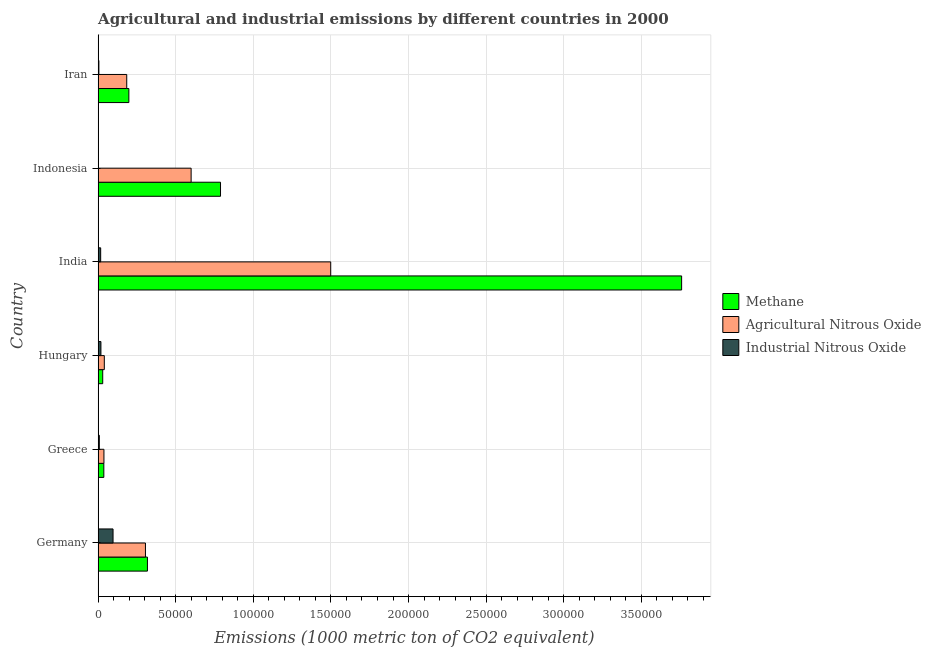How many different coloured bars are there?
Provide a succinct answer. 3. How many groups of bars are there?
Give a very brief answer. 6. Are the number of bars per tick equal to the number of legend labels?
Keep it short and to the point. Yes. How many bars are there on the 1st tick from the bottom?
Give a very brief answer. 3. What is the label of the 5th group of bars from the top?
Ensure brevity in your answer.  Greece. What is the amount of agricultural nitrous oxide emissions in Indonesia?
Keep it short and to the point. 5.99e+04. Across all countries, what is the maximum amount of agricultural nitrous oxide emissions?
Keep it short and to the point. 1.50e+05. Across all countries, what is the minimum amount of methane emissions?
Make the answer very short. 2961.9. In which country was the amount of agricultural nitrous oxide emissions maximum?
Your response must be concise. India. What is the total amount of agricultural nitrous oxide emissions in the graph?
Offer a very short reply. 2.66e+05. What is the difference between the amount of methane emissions in Germany and that in Greece?
Provide a succinct answer. 2.81e+04. What is the difference between the amount of agricultural nitrous oxide emissions in Iran and the amount of industrial nitrous oxide emissions in India?
Your response must be concise. 1.68e+04. What is the average amount of agricultural nitrous oxide emissions per country?
Make the answer very short. 4.44e+04. What is the difference between the amount of industrial nitrous oxide emissions and amount of methane emissions in Indonesia?
Provide a succinct answer. -7.87e+04. In how many countries, is the amount of agricultural nitrous oxide emissions greater than 210000 metric ton?
Offer a very short reply. 0. What is the ratio of the amount of methane emissions in India to that in Indonesia?
Ensure brevity in your answer.  4.77. Is the amount of industrial nitrous oxide emissions in Hungary less than that in Indonesia?
Ensure brevity in your answer.  No. What is the difference between the highest and the second highest amount of methane emissions?
Offer a terse response. 2.97e+05. What is the difference between the highest and the lowest amount of agricultural nitrous oxide emissions?
Make the answer very short. 1.46e+05. Is the sum of the amount of agricultural nitrous oxide emissions in Hungary and Iran greater than the maximum amount of methane emissions across all countries?
Offer a terse response. No. What does the 1st bar from the top in Hungary represents?
Make the answer very short. Industrial Nitrous Oxide. What does the 2nd bar from the bottom in Indonesia represents?
Offer a very short reply. Agricultural Nitrous Oxide. How many bars are there?
Keep it short and to the point. 18. Are all the bars in the graph horizontal?
Provide a succinct answer. Yes. How many countries are there in the graph?
Offer a very short reply. 6. Are the values on the major ticks of X-axis written in scientific E-notation?
Ensure brevity in your answer.  No. How are the legend labels stacked?
Your answer should be compact. Vertical. What is the title of the graph?
Your answer should be compact. Agricultural and industrial emissions by different countries in 2000. Does "Tertiary education" appear as one of the legend labels in the graph?
Offer a terse response. No. What is the label or title of the X-axis?
Provide a short and direct response. Emissions (1000 metric ton of CO2 equivalent). What is the label or title of the Y-axis?
Give a very brief answer. Country. What is the Emissions (1000 metric ton of CO2 equivalent) of Methane in Germany?
Offer a terse response. 3.18e+04. What is the Emissions (1000 metric ton of CO2 equivalent) in Agricultural Nitrous Oxide in Germany?
Make the answer very short. 3.05e+04. What is the Emissions (1000 metric ton of CO2 equivalent) in Industrial Nitrous Oxide in Germany?
Offer a terse response. 9617.9. What is the Emissions (1000 metric ton of CO2 equivalent) of Methane in Greece?
Give a very brief answer. 3679.3. What is the Emissions (1000 metric ton of CO2 equivalent) in Agricultural Nitrous Oxide in Greece?
Your answer should be compact. 3745.5. What is the Emissions (1000 metric ton of CO2 equivalent) of Industrial Nitrous Oxide in Greece?
Offer a terse response. 771. What is the Emissions (1000 metric ton of CO2 equivalent) in Methane in Hungary?
Offer a very short reply. 2961.9. What is the Emissions (1000 metric ton of CO2 equivalent) in Agricultural Nitrous Oxide in Hungary?
Provide a succinct answer. 3996.3. What is the Emissions (1000 metric ton of CO2 equivalent) of Industrial Nitrous Oxide in Hungary?
Your answer should be compact. 1805.4. What is the Emissions (1000 metric ton of CO2 equivalent) in Methane in India?
Make the answer very short. 3.76e+05. What is the Emissions (1000 metric ton of CO2 equivalent) of Agricultural Nitrous Oxide in India?
Provide a short and direct response. 1.50e+05. What is the Emissions (1000 metric ton of CO2 equivalent) of Industrial Nitrous Oxide in India?
Offer a terse response. 1643.3. What is the Emissions (1000 metric ton of CO2 equivalent) of Methane in Indonesia?
Offer a very short reply. 7.89e+04. What is the Emissions (1000 metric ton of CO2 equivalent) of Agricultural Nitrous Oxide in Indonesia?
Ensure brevity in your answer.  5.99e+04. What is the Emissions (1000 metric ton of CO2 equivalent) of Industrial Nitrous Oxide in Indonesia?
Provide a short and direct response. 175.8. What is the Emissions (1000 metric ton of CO2 equivalent) in Methane in Iran?
Provide a succinct answer. 1.98e+04. What is the Emissions (1000 metric ton of CO2 equivalent) in Agricultural Nitrous Oxide in Iran?
Provide a short and direct response. 1.84e+04. What is the Emissions (1000 metric ton of CO2 equivalent) in Industrial Nitrous Oxide in Iran?
Your answer should be very brief. 499.4. Across all countries, what is the maximum Emissions (1000 metric ton of CO2 equivalent) in Methane?
Give a very brief answer. 3.76e+05. Across all countries, what is the maximum Emissions (1000 metric ton of CO2 equivalent) of Agricultural Nitrous Oxide?
Give a very brief answer. 1.50e+05. Across all countries, what is the maximum Emissions (1000 metric ton of CO2 equivalent) in Industrial Nitrous Oxide?
Ensure brevity in your answer.  9617.9. Across all countries, what is the minimum Emissions (1000 metric ton of CO2 equivalent) in Methane?
Provide a succinct answer. 2961.9. Across all countries, what is the minimum Emissions (1000 metric ton of CO2 equivalent) of Agricultural Nitrous Oxide?
Give a very brief answer. 3745.5. Across all countries, what is the minimum Emissions (1000 metric ton of CO2 equivalent) in Industrial Nitrous Oxide?
Your answer should be very brief. 175.8. What is the total Emissions (1000 metric ton of CO2 equivalent) in Methane in the graph?
Provide a short and direct response. 5.13e+05. What is the total Emissions (1000 metric ton of CO2 equivalent) in Agricultural Nitrous Oxide in the graph?
Make the answer very short. 2.66e+05. What is the total Emissions (1000 metric ton of CO2 equivalent) of Industrial Nitrous Oxide in the graph?
Your answer should be compact. 1.45e+04. What is the difference between the Emissions (1000 metric ton of CO2 equivalent) in Methane in Germany and that in Greece?
Provide a short and direct response. 2.81e+04. What is the difference between the Emissions (1000 metric ton of CO2 equivalent) of Agricultural Nitrous Oxide in Germany and that in Greece?
Your answer should be very brief. 2.68e+04. What is the difference between the Emissions (1000 metric ton of CO2 equivalent) of Industrial Nitrous Oxide in Germany and that in Greece?
Offer a terse response. 8846.9. What is the difference between the Emissions (1000 metric ton of CO2 equivalent) of Methane in Germany and that in Hungary?
Your answer should be compact. 2.88e+04. What is the difference between the Emissions (1000 metric ton of CO2 equivalent) of Agricultural Nitrous Oxide in Germany and that in Hungary?
Give a very brief answer. 2.65e+04. What is the difference between the Emissions (1000 metric ton of CO2 equivalent) of Industrial Nitrous Oxide in Germany and that in Hungary?
Provide a succinct answer. 7812.5. What is the difference between the Emissions (1000 metric ton of CO2 equivalent) of Methane in Germany and that in India?
Give a very brief answer. -3.44e+05. What is the difference between the Emissions (1000 metric ton of CO2 equivalent) of Agricultural Nitrous Oxide in Germany and that in India?
Your answer should be very brief. -1.19e+05. What is the difference between the Emissions (1000 metric ton of CO2 equivalent) of Industrial Nitrous Oxide in Germany and that in India?
Keep it short and to the point. 7974.6. What is the difference between the Emissions (1000 metric ton of CO2 equivalent) of Methane in Germany and that in Indonesia?
Your answer should be compact. -4.71e+04. What is the difference between the Emissions (1000 metric ton of CO2 equivalent) in Agricultural Nitrous Oxide in Germany and that in Indonesia?
Provide a succinct answer. -2.94e+04. What is the difference between the Emissions (1000 metric ton of CO2 equivalent) in Industrial Nitrous Oxide in Germany and that in Indonesia?
Provide a short and direct response. 9442.1. What is the difference between the Emissions (1000 metric ton of CO2 equivalent) in Methane in Germany and that in Iran?
Your answer should be very brief. 1.20e+04. What is the difference between the Emissions (1000 metric ton of CO2 equivalent) in Agricultural Nitrous Oxide in Germany and that in Iran?
Offer a terse response. 1.21e+04. What is the difference between the Emissions (1000 metric ton of CO2 equivalent) of Industrial Nitrous Oxide in Germany and that in Iran?
Your answer should be very brief. 9118.5. What is the difference between the Emissions (1000 metric ton of CO2 equivalent) of Methane in Greece and that in Hungary?
Your response must be concise. 717.4. What is the difference between the Emissions (1000 metric ton of CO2 equivalent) in Agricultural Nitrous Oxide in Greece and that in Hungary?
Your answer should be very brief. -250.8. What is the difference between the Emissions (1000 metric ton of CO2 equivalent) of Industrial Nitrous Oxide in Greece and that in Hungary?
Your answer should be very brief. -1034.4. What is the difference between the Emissions (1000 metric ton of CO2 equivalent) in Methane in Greece and that in India?
Your response must be concise. -3.72e+05. What is the difference between the Emissions (1000 metric ton of CO2 equivalent) in Agricultural Nitrous Oxide in Greece and that in India?
Your response must be concise. -1.46e+05. What is the difference between the Emissions (1000 metric ton of CO2 equivalent) in Industrial Nitrous Oxide in Greece and that in India?
Offer a terse response. -872.3. What is the difference between the Emissions (1000 metric ton of CO2 equivalent) in Methane in Greece and that in Indonesia?
Offer a terse response. -7.52e+04. What is the difference between the Emissions (1000 metric ton of CO2 equivalent) in Agricultural Nitrous Oxide in Greece and that in Indonesia?
Offer a terse response. -5.62e+04. What is the difference between the Emissions (1000 metric ton of CO2 equivalent) of Industrial Nitrous Oxide in Greece and that in Indonesia?
Offer a terse response. 595.2. What is the difference between the Emissions (1000 metric ton of CO2 equivalent) in Methane in Greece and that in Iran?
Your answer should be very brief. -1.61e+04. What is the difference between the Emissions (1000 metric ton of CO2 equivalent) of Agricultural Nitrous Oxide in Greece and that in Iran?
Offer a very short reply. -1.47e+04. What is the difference between the Emissions (1000 metric ton of CO2 equivalent) in Industrial Nitrous Oxide in Greece and that in Iran?
Offer a terse response. 271.6. What is the difference between the Emissions (1000 metric ton of CO2 equivalent) in Methane in Hungary and that in India?
Keep it short and to the point. -3.73e+05. What is the difference between the Emissions (1000 metric ton of CO2 equivalent) of Agricultural Nitrous Oxide in Hungary and that in India?
Provide a succinct answer. -1.46e+05. What is the difference between the Emissions (1000 metric ton of CO2 equivalent) in Industrial Nitrous Oxide in Hungary and that in India?
Offer a very short reply. 162.1. What is the difference between the Emissions (1000 metric ton of CO2 equivalent) in Methane in Hungary and that in Indonesia?
Offer a terse response. -7.59e+04. What is the difference between the Emissions (1000 metric ton of CO2 equivalent) of Agricultural Nitrous Oxide in Hungary and that in Indonesia?
Give a very brief answer. -5.59e+04. What is the difference between the Emissions (1000 metric ton of CO2 equivalent) of Industrial Nitrous Oxide in Hungary and that in Indonesia?
Your answer should be very brief. 1629.6. What is the difference between the Emissions (1000 metric ton of CO2 equivalent) of Methane in Hungary and that in Iran?
Offer a very short reply. -1.68e+04. What is the difference between the Emissions (1000 metric ton of CO2 equivalent) of Agricultural Nitrous Oxide in Hungary and that in Iran?
Keep it short and to the point. -1.44e+04. What is the difference between the Emissions (1000 metric ton of CO2 equivalent) in Industrial Nitrous Oxide in Hungary and that in Iran?
Keep it short and to the point. 1306. What is the difference between the Emissions (1000 metric ton of CO2 equivalent) in Methane in India and that in Indonesia?
Provide a short and direct response. 2.97e+05. What is the difference between the Emissions (1000 metric ton of CO2 equivalent) of Agricultural Nitrous Oxide in India and that in Indonesia?
Your response must be concise. 8.99e+04. What is the difference between the Emissions (1000 metric ton of CO2 equivalent) of Industrial Nitrous Oxide in India and that in Indonesia?
Your response must be concise. 1467.5. What is the difference between the Emissions (1000 metric ton of CO2 equivalent) of Methane in India and that in Iran?
Provide a short and direct response. 3.56e+05. What is the difference between the Emissions (1000 metric ton of CO2 equivalent) in Agricultural Nitrous Oxide in India and that in Iran?
Your answer should be compact. 1.31e+05. What is the difference between the Emissions (1000 metric ton of CO2 equivalent) in Industrial Nitrous Oxide in India and that in Iran?
Offer a terse response. 1143.9. What is the difference between the Emissions (1000 metric ton of CO2 equivalent) of Methane in Indonesia and that in Iran?
Ensure brevity in your answer.  5.91e+04. What is the difference between the Emissions (1000 metric ton of CO2 equivalent) of Agricultural Nitrous Oxide in Indonesia and that in Iran?
Your answer should be very brief. 4.15e+04. What is the difference between the Emissions (1000 metric ton of CO2 equivalent) of Industrial Nitrous Oxide in Indonesia and that in Iran?
Provide a short and direct response. -323.6. What is the difference between the Emissions (1000 metric ton of CO2 equivalent) of Methane in Germany and the Emissions (1000 metric ton of CO2 equivalent) of Agricultural Nitrous Oxide in Greece?
Offer a very short reply. 2.80e+04. What is the difference between the Emissions (1000 metric ton of CO2 equivalent) in Methane in Germany and the Emissions (1000 metric ton of CO2 equivalent) in Industrial Nitrous Oxide in Greece?
Your answer should be very brief. 3.10e+04. What is the difference between the Emissions (1000 metric ton of CO2 equivalent) of Agricultural Nitrous Oxide in Germany and the Emissions (1000 metric ton of CO2 equivalent) of Industrial Nitrous Oxide in Greece?
Keep it short and to the point. 2.97e+04. What is the difference between the Emissions (1000 metric ton of CO2 equivalent) of Methane in Germany and the Emissions (1000 metric ton of CO2 equivalent) of Agricultural Nitrous Oxide in Hungary?
Give a very brief answer. 2.78e+04. What is the difference between the Emissions (1000 metric ton of CO2 equivalent) in Methane in Germany and the Emissions (1000 metric ton of CO2 equivalent) in Industrial Nitrous Oxide in Hungary?
Offer a terse response. 3.00e+04. What is the difference between the Emissions (1000 metric ton of CO2 equivalent) in Agricultural Nitrous Oxide in Germany and the Emissions (1000 metric ton of CO2 equivalent) in Industrial Nitrous Oxide in Hungary?
Your answer should be very brief. 2.87e+04. What is the difference between the Emissions (1000 metric ton of CO2 equivalent) of Methane in Germany and the Emissions (1000 metric ton of CO2 equivalent) of Agricultural Nitrous Oxide in India?
Give a very brief answer. -1.18e+05. What is the difference between the Emissions (1000 metric ton of CO2 equivalent) of Methane in Germany and the Emissions (1000 metric ton of CO2 equivalent) of Industrial Nitrous Oxide in India?
Provide a succinct answer. 3.01e+04. What is the difference between the Emissions (1000 metric ton of CO2 equivalent) of Agricultural Nitrous Oxide in Germany and the Emissions (1000 metric ton of CO2 equivalent) of Industrial Nitrous Oxide in India?
Your response must be concise. 2.89e+04. What is the difference between the Emissions (1000 metric ton of CO2 equivalent) of Methane in Germany and the Emissions (1000 metric ton of CO2 equivalent) of Agricultural Nitrous Oxide in Indonesia?
Your answer should be very brief. -2.82e+04. What is the difference between the Emissions (1000 metric ton of CO2 equivalent) of Methane in Germany and the Emissions (1000 metric ton of CO2 equivalent) of Industrial Nitrous Oxide in Indonesia?
Your answer should be very brief. 3.16e+04. What is the difference between the Emissions (1000 metric ton of CO2 equivalent) in Agricultural Nitrous Oxide in Germany and the Emissions (1000 metric ton of CO2 equivalent) in Industrial Nitrous Oxide in Indonesia?
Your answer should be compact. 3.03e+04. What is the difference between the Emissions (1000 metric ton of CO2 equivalent) in Methane in Germany and the Emissions (1000 metric ton of CO2 equivalent) in Agricultural Nitrous Oxide in Iran?
Provide a short and direct response. 1.33e+04. What is the difference between the Emissions (1000 metric ton of CO2 equivalent) in Methane in Germany and the Emissions (1000 metric ton of CO2 equivalent) in Industrial Nitrous Oxide in Iran?
Your answer should be very brief. 3.13e+04. What is the difference between the Emissions (1000 metric ton of CO2 equivalent) in Agricultural Nitrous Oxide in Germany and the Emissions (1000 metric ton of CO2 equivalent) in Industrial Nitrous Oxide in Iran?
Provide a short and direct response. 3.00e+04. What is the difference between the Emissions (1000 metric ton of CO2 equivalent) in Methane in Greece and the Emissions (1000 metric ton of CO2 equivalent) in Agricultural Nitrous Oxide in Hungary?
Provide a short and direct response. -317. What is the difference between the Emissions (1000 metric ton of CO2 equivalent) in Methane in Greece and the Emissions (1000 metric ton of CO2 equivalent) in Industrial Nitrous Oxide in Hungary?
Your answer should be compact. 1873.9. What is the difference between the Emissions (1000 metric ton of CO2 equivalent) in Agricultural Nitrous Oxide in Greece and the Emissions (1000 metric ton of CO2 equivalent) in Industrial Nitrous Oxide in Hungary?
Offer a very short reply. 1940.1. What is the difference between the Emissions (1000 metric ton of CO2 equivalent) in Methane in Greece and the Emissions (1000 metric ton of CO2 equivalent) in Agricultural Nitrous Oxide in India?
Your response must be concise. -1.46e+05. What is the difference between the Emissions (1000 metric ton of CO2 equivalent) of Methane in Greece and the Emissions (1000 metric ton of CO2 equivalent) of Industrial Nitrous Oxide in India?
Keep it short and to the point. 2036. What is the difference between the Emissions (1000 metric ton of CO2 equivalent) of Agricultural Nitrous Oxide in Greece and the Emissions (1000 metric ton of CO2 equivalent) of Industrial Nitrous Oxide in India?
Keep it short and to the point. 2102.2. What is the difference between the Emissions (1000 metric ton of CO2 equivalent) in Methane in Greece and the Emissions (1000 metric ton of CO2 equivalent) in Agricultural Nitrous Oxide in Indonesia?
Make the answer very short. -5.62e+04. What is the difference between the Emissions (1000 metric ton of CO2 equivalent) in Methane in Greece and the Emissions (1000 metric ton of CO2 equivalent) in Industrial Nitrous Oxide in Indonesia?
Provide a short and direct response. 3503.5. What is the difference between the Emissions (1000 metric ton of CO2 equivalent) in Agricultural Nitrous Oxide in Greece and the Emissions (1000 metric ton of CO2 equivalent) in Industrial Nitrous Oxide in Indonesia?
Provide a succinct answer. 3569.7. What is the difference between the Emissions (1000 metric ton of CO2 equivalent) in Methane in Greece and the Emissions (1000 metric ton of CO2 equivalent) in Agricultural Nitrous Oxide in Iran?
Your response must be concise. -1.48e+04. What is the difference between the Emissions (1000 metric ton of CO2 equivalent) in Methane in Greece and the Emissions (1000 metric ton of CO2 equivalent) in Industrial Nitrous Oxide in Iran?
Ensure brevity in your answer.  3179.9. What is the difference between the Emissions (1000 metric ton of CO2 equivalent) of Agricultural Nitrous Oxide in Greece and the Emissions (1000 metric ton of CO2 equivalent) of Industrial Nitrous Oxide in Iran?
Offer a very short reply. 3246.1. What is the difference between the Emissions (1000 metric ton of CO2 equivalent) of Methane in Hungary and the Emissions (1000 metric ton of CO2 equivalent) of Agricultural Nitrous Oxide in India?
Your answer should be very brief. -1.47e+05. What is the difference between the Emissions (1000 metric ton of CO2 equivalent) of Methane in Hungary and the Emissions (1000 metric ton of CO2 equivalent) of Industrial Nitrous Oxide in India?
Keep it short and to the point. 1318.6. What is the difference between the Emissions (1000 metric ton of CO2 equivalent) of Agricultural Nitrous Oxide in Hungary and the Emissions (1000 metric ton of CO2 equivalent) of Industrial Nitrous Oxide in India?
Your answer should be compact. 2353. What is the difference between the Emissions (1000 metric ton of CO2 equivalent) in Methane in Hungary and the Emissions (1000 metric ton of CO2 equivalent) in Agricultural Nitrous Oxide in Indonesia?
Your answer should be very brief. -5.70e+04. What is the difference between the Emissions (1000 metric ton of CO2 equivalent) in Methane in Hungary and the Emissions (1000 metric ton of CO2 equivalent) in Industrial Nitrous Oxide in Indonesia?
Give a very brief answer. 2786.1. What is the difference between the Emissions (1000 metric ton of CO2 equivalent) of Agricultural Nitrous Oxide in Hungary and the Emissions (1000 metric ton of CO2 equivalent) of Industrial Nitrous Oxide in Indonesia?
Your answer should be very brief. 3820.5. What is the difference between the Emissions (1000 metric ton of CO2 equivalent) of Methane in Hungary and the Emissions (1000 metric ton of CO2 equivalent) of Agricultural Nitrous Oxide in Iran?
Ensure brevity in your answer.  -1.55e+04. What is the difference between the Emissions (1000 metric ton of CO2 equivalent) in Methane in Hungary and the Emissions (1000 metric ton of CO2 equivalent) in Industrial Nitrous Oxide in Iran?
Your answer should be very brief. 2462.5. What is the difference between the Emissions (1000 metric ton of CO2 equivalent) in Agricultural Nitrous Oxide in Hungary and the Emissions (1000 metric ton of CO2 equivalent) in Industrial Nitrous Oxide in Iran?
Provide a short and direct response. 3496.9. What is the difference between the Emissions (1000 metric ton of CO2 equivalent) in Methane in India and the Emissions (1000 metric ton of CO2 equivalent) in Agricultural Nitrous Oxide in Indonesia?
Your answer should be very brief. 3.16e+05. What is the difference between the Emissions (1000 metric ton of CO2 equivalent) of Methane in India and the Emissions (1000 metric ton of CO2 equivalent) of Industrial Nitrous Oxide in Indonesia?
Your answer should be compact. 3.76e+05. What is the difference between the Emissions (1000 metric ton of CO2 equivalent) in Agricultural Nitrous Oxide in India and the Emissions (1000 metric ton of CO2 equivalent) in Industrial Nitrous Oxide in Indonesia?
Provide a short and direct response. 1.50e+05. What is the difference between the Emissions (1000 metric ton of CO2 equivalent) of Methane in India and the Emissions (1000 metric ton of CO2 equivalent) of Agricultural Nitrous Oxide in Iran?
Give a very brief answer. 3.58e+05. What is the difference between the Emissions (1000 metric ton of CO2 equivalent) in Methane in India and the Emissions (1000 metric ton of CO2 equivalent) in Industrial Nitrous Oxide in Iran?
Your answer should be very brief. 3.75e+05. What is the difference between the Emissions (1000 metric ton of CO2 equivalent) in Agricultural Nitrous Oxide in India and the Emissions (1000 metric ton of CO2 equivalent) in Industrial Nitrous Oxide in Iran?
Ensure brevity in your answer.  1.49e+05. What is the difference between the Emissions (1000 metric ton of CO2 equivalent) of Methane in Indonesia and the Emissions (1000 metric ton of CO2 equivalent) of Agricultural Nitrous Oxide in Iran?
Provide a succinct answer. 6.04e+04. What is the difference between the Emissions (1000 metric ton of CO2 equivalent) of Methane in Indonesia and the Emissions (1000 metric ton of CO2 equivalent) of Industrial Nitrous Oxide in Iran?
Make the answer very short. 7.84e+04. What is the difference between the Emissions (1000 metric ton of CO2 equivalent) in Agricultural Nitrous Oxide in Indonesia and the Emissions (1000 metric ton of CO2 equivalent) in Industrial Nitrous Oxide in Iran?
Your answer should be very brief. 5.94e+04. What is the average Emissions (1000 metric ton of CO2 equivalent) of Methane per country?
Ensure brevity in your answer.  8.55e+04. What is the average Emissions (1000 metric ton of CO2 equivalent) in Agricultural Nitrous Oxide per country?
Ensure brevity in your answer.  4.44e+04. What is the average Emissions (1000 metric ton of CO2 equivalent) in Industrial Nitrous Oxide per country?
Your answer should be compact. 2418.8. What is the difference between the Emissions (1000 metric ton of CO2 equivalent) of Methane and Emissions (1000 metric ton of CO2 equivalent) of Agricultural Nitrous Oxide in Germany?
Ensure brevity in your answer.  1273.5. What is the difference between the Emissions (1000 metric ton of CO2 equivalent) of Methane and Emissions (1000 metric ton of CO2 equivalent) of Industrial Nitrous Oxide in Germany?
Provide a succinct answer. 2.22e+04. What is the difference between the Emissions (1000 metric ton of CO2 equivalent) of Agricultural Nitrous Oxide and Emissions (1000 metric ton of CO2 equivalent) of Industrial Nitrous Oxide in Germany?
Your response must be concise. 2.09e+04. What is the difference between the Emissions (1000 metric ton of CO2 equivalent) of Methane and Emissions (1000 metric ton of CO2 equivalent) of Agricultural Nitrous Oxide in Greece?
Give a very brief answer. -66.2. What is the difference between the Emissions (1000 metric ton of CO2 equivalent) of Methane and Emissions (1000 metric ton of CO2 equivalent) of Industrial Nitrous Oxide in Greece?
Provide a succinct answer. 2908.3. What is the difference between the Emissions (1000 metric ton of CO2 equivalent) in Agricultural Nitrous Oxide and Emissions (1000 metric ton of CO2 equivalent) in Industrial Nitrous Oxide in Greece?
Give a very brief answer. 2974.5. What is the difference between the Emissions (1000 metric ton of CO2 equivalent) in Methane and Emissions (1000 metric ton of CO2 equivalent) in Agricultural Nitrous Oxide in Hungary?
Offer a terse response. -1034.4. What is the difference between the Emissions (1000 metric ton of CO2 equivalent) of Methane and Emissions (1000 metric ton of CO2 equivalent) of Industrial Nitrous Oxide in Hungary?
Your response must be concise. 1156.5. What is the difference between the Emissions (1000 metric ton of CO2 equivalent) in Agricultural Nitrous Oxide and Emissions (1000 metric ton of CO2 equivalent) in Industrial Nitrous Oxide in Hungary?
Give a very brief answer. 2190.9. What is the difference between the Emissions (1000 metric ton of CO2 equivalent) in Methane and Emissions (1000 metric ton of CO2 equivalent) in Agricultural Nitrous Oxide in India?
Offer a very short reply. 2.26e+05. What is the difference between the Emissions (1000 metric ton of CO2 equivalent) in Methane and Emissions (1000 metric ton of CO2 equivalent) in Industrial Nitrous Oxide in India?
Your response must be concise. 3.74e+05. What is the difference between the Emissions (1000 metric ton of CO2 equivalent) of Agricultural Nitrous Oxide and Emissions (1000 metric ton of CO2 equivalent) of Industrial Nitrous Oxide in India?
Offer a terse response. 1.48e+05. What is the difference between the Emissions (1000 metric ton of CO2 equivalent) of Methane and Emissions (1000 metric ton of CO2 equivalent) of Agricultural Nitrous Oxide in Indonesia?
Your response must be concise. 1.89e+04. What is the difference between the Emissions (1000 metric ton of CO2 equivalent) of Methane and Emissions (1000 metric ton of CO2 equivalent) of Industrial Nitrous Oxide in Indonesia?
Your answer should be compact. 7.87e+04. What is the difference between the Emissions (1000 metric ton of CO2 equivalent) of Agricultural Nitrous Oxide and Emissions (1000 metric ton of CO2 equivalent) of Industrial Nitrous Oxide in Indonesia?
Keep it short and to the point. 5.98e+04. What is the difference between the Emissions (1000 metric ton of CO2 equivalent) in Methane and Emissions (1000 metric ton of CO2 equivalent) in Agricultural Nitrous Oxide in Iran?
Give a very brief answer. 1362. What is the difference between the Emissions (1000 metric ton of CO2 equivalent) of Methane and Emissions (1000 metric ton of CO2 equivalent) of Industrial Nitrous Oxide in Iran?
Make the answer very short. 1.93e+04. What is the difference between the Emissions (1000 metric ton of CO2 equivalent) in Agricultural Nitrous Oxide and Emissions (1000 metric ton of CO2 equivalent) in Industrial Nitrous Oxide in Iran?
Provide a succinct answer. 1.79e+04. What is the ratio of the Emissions (1000 metric ton of CO2 equivalent) in Methane in Germany to that in Greece?
Make the answer very short. 8.64. What is the ratio of the Emissions (1000 metric ton of CO2 equivalent) of Agricultural Nitrous Oxide in Germany to that in Greece?
Offer a terse response. 8.14. What is the ratio of the Emissions (1000 metric ton of CO2 equivalent) of Industrial Nitrous Oxide in Germany to that in Greece?
Make the answer very short. 12.47. What is the ratio of the Emissions (1000 metric ton of CO2 equivalent) of Methane in Germany to that in Hungary?
Ensure brevity in your answer.  10.73. What is the ratio of the Emissions (1000 metric ton of CO2 equivalent) in Agricultural Nitrous Oxide in Germany to that in Hungary?
Ensure brevity in your answer.  7.63. What is the ratio of the Emissions (1000 metric ton of CO2 equivalent) of Industrial Nitrous Oxide in Germany to that in Hungary?
Ensure brevity in your answer.  5.33. What is the ratio of the Emissions (1000 metric ton of CO2 equivalent) of Methane in Germany to that in India?
Keep it short and to the point. 0.08. What is the ratio of the Emissions (1000 metric ton of CO2 equivalent) of Agricultural Nitrous Oxide in Germany to that in India?
Offer a very short reply. 0.2. What is the ratio of the Emissions (1000 metric ton of CO2 equivalent) in Industrial Nitrous Oxide in Germany to that in India?
Your answer should be very brief. 5.85. What is the ratio of the Emissions (1000 metric ton of CO2 equivalent) of Methane in Germany to that in Indonesia?
Offer a very short reply. 0.4. What is the ratio of the Emissions (1000 metric ton of CO2 equivalent) of Agricultural Nitrous Oxide in Germany to that in Indonesia?
Keep it short and to the point. 0.51. What is the ratio of the Emissions (1000 metric ton of CO2 equivalent) of Industrial Nitrous Oxide in Germany to that in Indonesia?
Offer a very short reply. 54.71. What is the ratio of the Emissions (1000 metric ton of CO2 equivalent) in Methane in Germany to that in Iran?
Provide a short and direct response. 1.6. What is the ratio of the Emissions (1000 metric ton of CO2 equivalent) in Agricultural Nitrous Oxide in Germany to that in Iran?
Keep it short and to the point. 1.65. What is the ratio of the Emissions (1000 metric ton of CO2 equivalent) of Industrial Nitrous Oxide in Germany to that in Iran?
Your response must be concise. 19.26. What is the ratio of the Emissions (1000 metric ton of CO2 equivalent) of Methane in Greece to that in Hungary?
Your answer should be very brief. 1.24. What is the ratio of the Emissions (1000 metric ton of CO2 equivalent) of Agricultural Nitrous Oxide in Greece to that in Hungary?
Your answer should be very brief. 0.94. What is the ratio of the Emissions (1000 metric ton of CO2 equivalent) of Industrial Nitrous Oxide in Greece to that in Hungary?
Provide a short and direct response. 0.43. What is the ratio of the Emissions (1000 metric ton of CO2 equivalent) in Methane in Greece to that in India?
Your answer should be very brief. 0.01. What is the ratio of the Emissions (1000 metric ton of CO2 equivalent) in Agricultural Nitrous Oxide in Greece to that in India?
Provide a succinct answer. 0.03. What is the ratio of the Emissions (1000 metric ton of CO2 equivalent) of Industrial Nitrous Oxide in Greece to that in India?
Offer a terse response. 0.47. What is the ratio of the Emissions (1000 metric ton of CO2 equivalent) of Methane in Greece to that in Indonesia?
Offer a very short reply. 0.05. What is the ratio of the Emissions (1000 metric ton of CO2 equivalent) in Agricultural Nitrous Oxide in Greece to that in Indonesia?
Offer a very short reply. 0.06. What is the ratio of the Emissions (1000 metric ton of CO2 equivalent) of Industrial Nitrous Oxide in Greece to that in Indonesia?
Your response must be concise. 4.39. What is the ratio of the Emissions (1000 metric ton of CO2 equivalent) in Methane in Greece to that in Iran?
Your answer should be compact. 0.19. What is the ratio of the Emissions (1000 metric ton of CO2 equivalent) of Agricultural Nitrous Oxide in Greece to that in Iran?
Make the answer very short. 0.2. What is the ratio of the Emissions (1000 metric ton of CO2 equivalent) of Industrial Nitrous Oxide in Greece to that in Iran?
Provide a short and direct response. 1.54. What is the ratio of the Emissions (1000 metric ton of CO2 equivalent) in Methane in Hungary to that in India?
Provide a succinct answer. 0.01. What is the ratio of the Emissions (1000 metric ton of CO2 equivalent) in Agricultural Nitrous Oxide in Hungary to that in India?
Offer a terse response. 0.03. What is the ratio of the Emissions (1000 metric ton of CO2 equivalent) of Industrial Nitrous Oxide in Hungary to that in India?
Provide a succinct answer. 1.1. What is the ratio of the Emissions (1000 metric ton of CO2 equivalent) in Methane in Hungary to that in Indonesia?
Your response must be concise. 0.04. What is the ratio of the Emissions (1000 metric ton of CO2 equivalent) in Agricultural Nitrous Oxide in Hungary to that in Indonesia?
Offer a very short reply. 0.07. What is the ratio of the Emissions (1000 metric ton of CO2 equivalent) of Industrial Nitrous Oxide in Hungary to that in Indonesia?
Your response must be concise. 10.27. What is the ratio of the Emissions (1000 metric ton of CO2 equivalent) of Methane in Hungary to that in Iran?
Provide a succinct answer. 0.15. What is the ratio of the Emissions (1000 metric ton of CO2 equivalent) of Agricultural Nitrous Oxide in Hungary to that in Iran?
Keep it short and to the point. 0.22. What is the ratio of the Emissions (1000 metric ton of CO2 equivalent) in Industrial Nitrous Oxide in Hungary to that in Iran?
Provide a succinct answer. 3.62. What is the ratio of the Emissions (1000 metric ton of CO2 equivalent) in Methane in India to that in Indonesia?
Your response must be concise. 4.77. What is the ratio of the Emissions (1000 metric ton of CO2 equivalent) in Agricultural Nitrous Oxide in India to that in Indonesia?
Your answer should be very brief. 2.5. What is the ratio of the Emissions (1000 metric ton of CO2 equivalent) in Industrial Nitrous Oxide in India to that in Indonesia?
Your answer should be compact. 9.35. What is the ratio of the Emissions (1000 metric ton of CO2 equivalent) of Methane in India to that in Iran?
Your answer should be compact. 18.98. What is the ratio of the Emissions (1000 metric ton of CO2 equivalent) in Agricultural Nitrous Oxide in India to that in Iran?
Provide a short and direct response. 8.13. What is the ratio of the Emissions (1000 metric ton of CO2 equivalent) of Industrial Nitrous Oxide in India to that in Iran?
Offer a terse response. 3.29. What is the ratio of the Emissions (1000 metric ton of CO2 equivalent) of Methane in Indonesia to that in Iran?
Offer a very short reply. 3.98. What is the ratio of the Emissions (1000 metric ton of CO2 equivalent) in Agricultural Nitrous Oxide in Indonesia to that in Iran?
Your answer should be very brief. 3.25. What is the ratio of the Emissions (1000 metric ton of CO2 equivalent) of Industrial Nitrous Oxide in Indonesia to that in Iran?
Offer a terse response. 0.35. What is the difference between the highest and the second highest Emissions (1000 metric ton of CO2 equivalent) in Methane?
Keep it short and to the point. 2.97e+05. What is the difference between the highest and the second highest Emissions (1000 metric ton of CO2 equivalent) of Agricultural Nitrous Oxide?
Keep it short and to the point. 8.99e+04. What is the difference between the highest and the second highest Emissions (1000 metric ton of CO2 equivalent) of Industrial Nitrous Oxide?
Your answer should be compact. 7812.5. What is the difference between the highest and the lowest Emissions (1000 metric ton of CO2 equivalent) of Methane?
Give a very brief answer. 3.73e+05. What is the difference between the highest and the lowest Emissions (1000 metric ton of CO2 equivalent) of Agricultural Nitrous Oxide?
Give a very brief answer. 1.46e+05. What is the difference between the highest and the lowest Emissions (1000 metric ton of CO2 equivalent) of Industrial Nitrous Oxide?
Offer a terse response. 9442.1. 